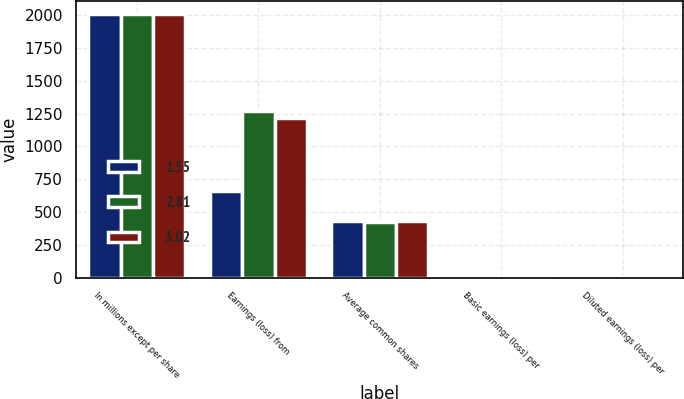Convert chart. <chart><loc_0><loc_0><loc_500><loc_500><stacked_bar_chart><ecel><fcel>In millions except per share<fcel>Earnings (loss) from<fcel>Average common shares<fcel>Basic earnings (loss) per<fcel>Diluted earnings (loss) per<nl><fcel>1.55<fcel>2009<fcel>663<fcel>428<fcel>1.56<fcel>1.55<nl><fcel>2.81<fcel>2008<fcel>1269<fcel>421<fcel>3.02<fcel>3.02<nl><fcel>3.02<fcel>2007<fcel>1215<fcel>433<fcel>2.83<fcel>2.81<nl></chart> 